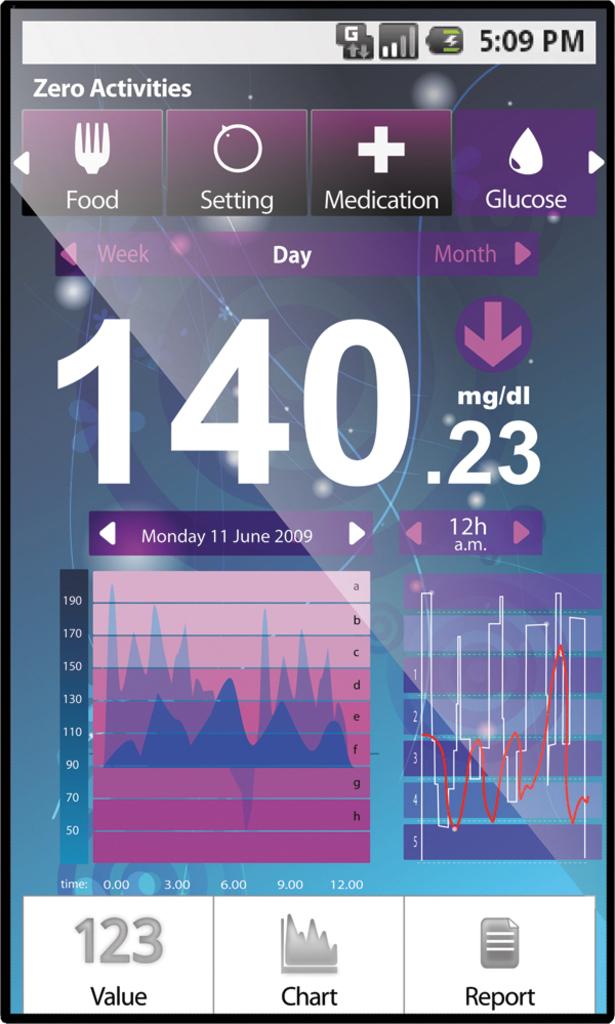What day is it?
Your answer should be compact. Monday. What time does the phone say?
Make the answer very short. 5:09 pm. 